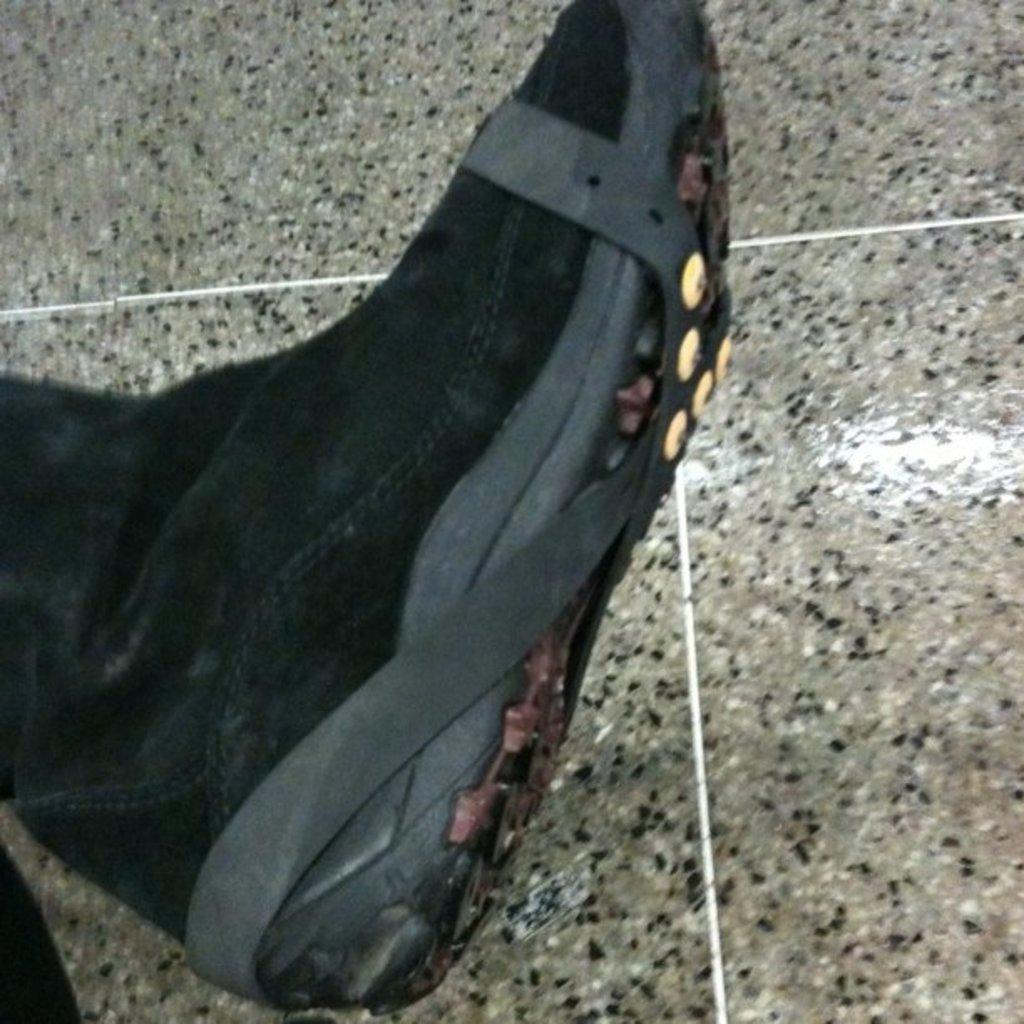What object is present on the floor in the image? There is a shoe in the image. What is the color of the shoe? The shoe is black in color. Where is the shoe located in the image? The shoe is on the floor. What is the color of the floor? The floor is black and ash in color. Is there a woman wearing the shoe in the image? There is no woman present in the image, only the shoe on the floor. What type of friction can be observed between the shoe and the floor in the image? The image does not provide information about the friction between the shoe and the floor, as it only shows the shoe's position on the floor. 